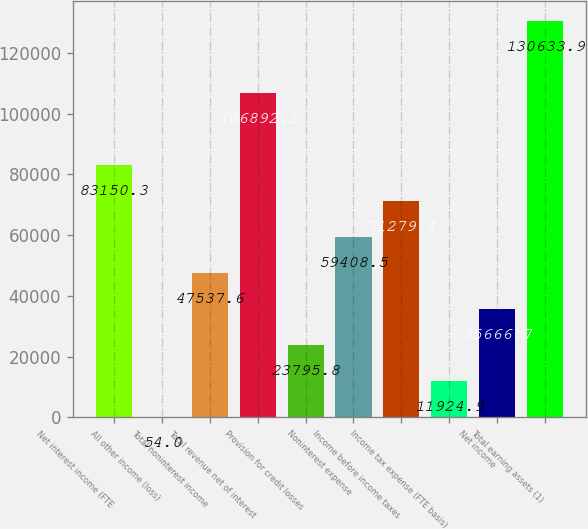Convert chart to OTSL. <chart><loc_0><loc_0><loc_500><loc_500><bar_chart><fcel>Net interest income (FTE<fcel>All other income (loss)<fcel>Total noninterest income<fcel>Total revenue net of interest<fcel>Provision for credit losses<fcel>Noninterest expense<fcel>Income before income taxes<fcel>Income tax expense (FTE basis)<fcel>Net income<fcel>Total earning assets (1)<nl><fcel>83150.3<fcel>54<fcel>47537.6<fcel>106892<fcel>23795.8<fcel>59408.5<fcel>71279.4<fcel>11924.9<fcel>35666.7<fcel>130634<nl></chart> 